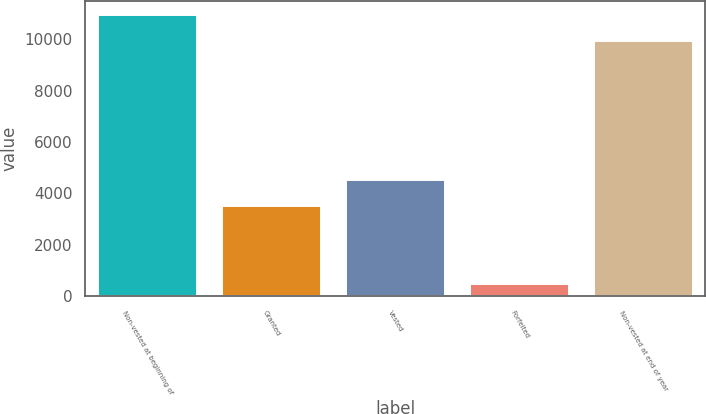Convert chart to OTSL. <chart><loc_0><loc_0><loc_500><loc_500><bar_chart><fcel>Non-vested at beginning of<fcel>Granted<fcel>Vested<fcel>Forfeited<fcel>Non-vested at end of year<nl><fcel>10934.3<fcel>3506<fcel>4524.3<fcel>491<fcel>9916<nl></chart> 